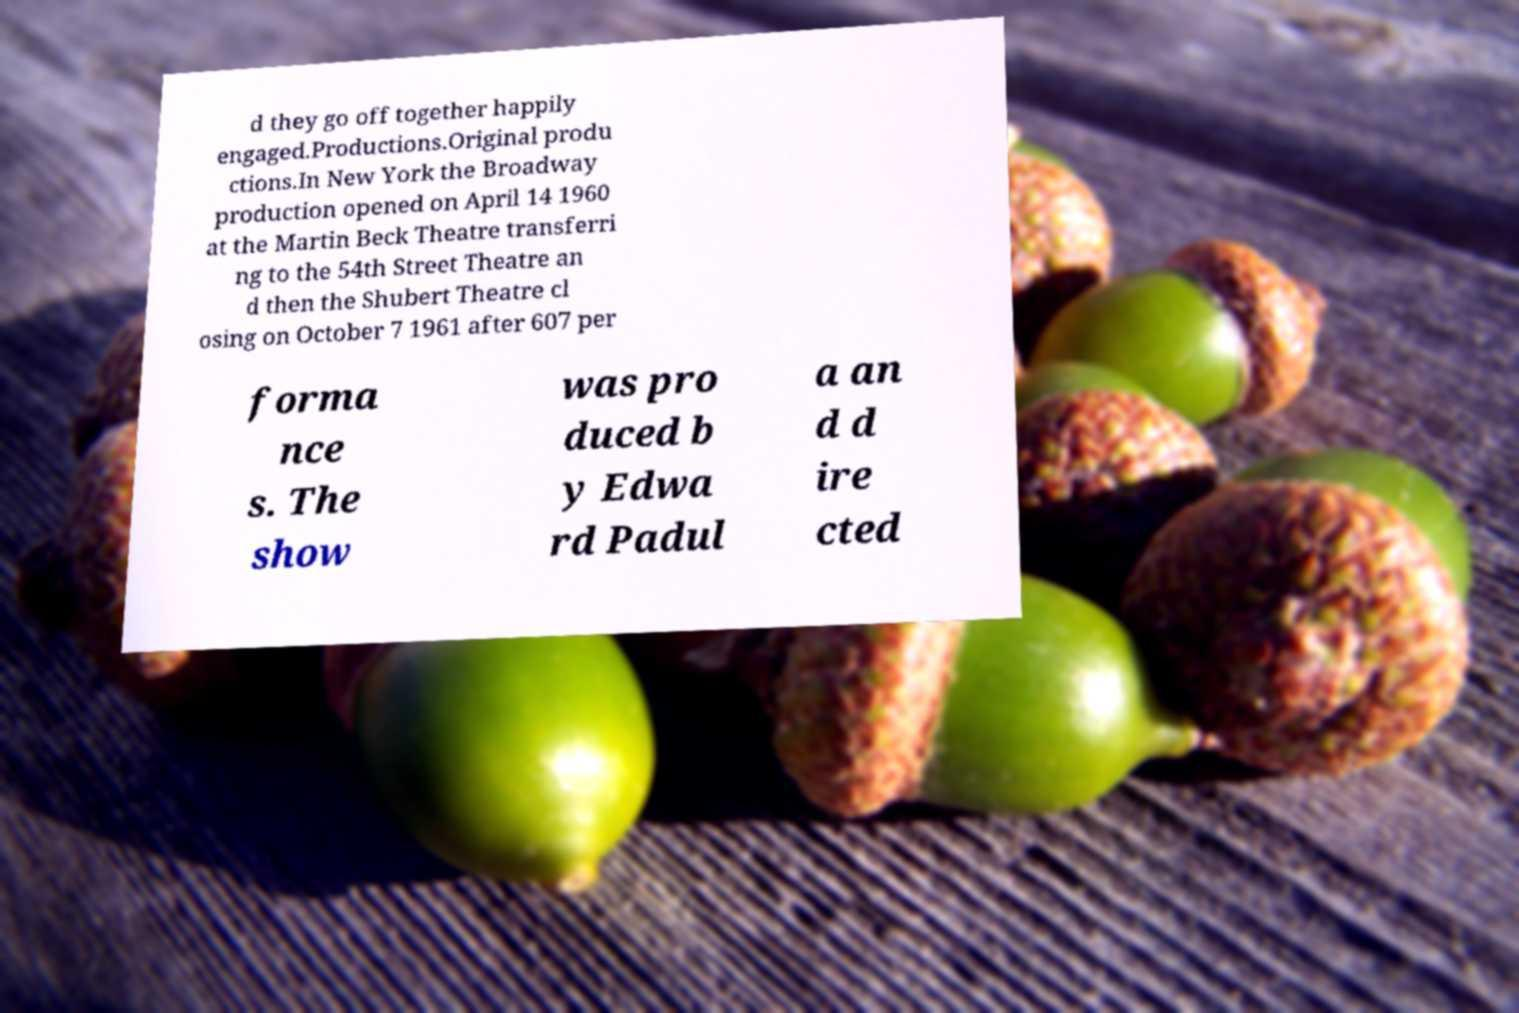Could you assist in decoding the text presented in this image and type it out clearly? d they go off together happily engaged.Productions.Original produ ctions.In New York the Broadway production opened on April 14 1960 at the Martin Beck Theatre transferri ng to the 54th Street Theatre an d then the Shubert Theatre cl osing on October 7 1961 after 607 per forma nce s. The show was pro duced b y Edwa rd Padul a an d d ire cted 